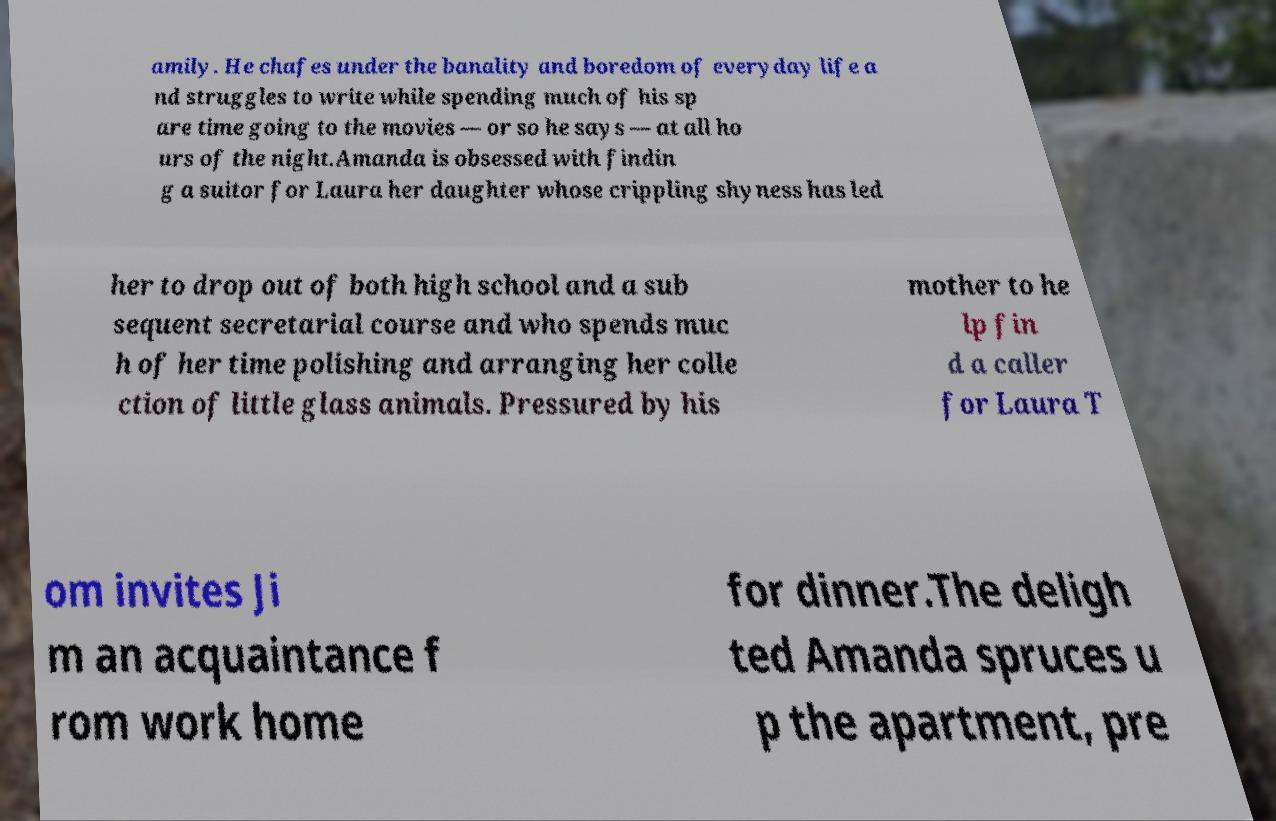There's text embedded in this image that I need extracted. Can you transcribe it verbatim? amily. He chafes under the banality and boredom of everyday life a nd struggles to write while spending much of his sp are time going to the movies — or so he says — at all ho urs of the night.Amanda is obsessed with findin g a suitor for Laura her daughter whose crippling shyness has led her to drop out of both high school and a sub sequent secretarial course and who spends muc h of her time polishing and arranging her colle ction of little glass animals. Pressured by his mother to he lp fin d a caller for Laura T om invites Ji m an acquaintance f rom work home for dinner.The deligh ted Amanda spruces u p the apartment, pre 